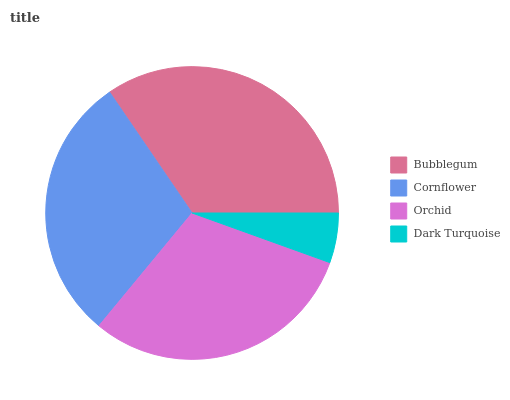Is Dark Turquoise the minimum?
Answer yes or no. Yes. Is Bubblegum the maximum?
Answer yes or no. Yes. Is Cornflower the minimum?
Answer yes or no. No. Is Cornflower the maximum?
Answer yes or no. No. Is Bubblegum greater than Cornflower?
Answer yes or no. Yes. Is Cornflower less than Bubblegum?
Answer yes or no. Yes. Is Cornflower greater than Bubblegum?
Answer yes or no. No. Is Bubblegum less than Cornflower?
Answer yes or no. No. Is Orchid the high median?
Answer yes or no. Yes. Is Cornflower the low median?
Answer yes or no. Yes. Is Bubblegum the high median?
Answer yes or no. No. Is Bubblegum the low median?
Answer yes or no. No. 